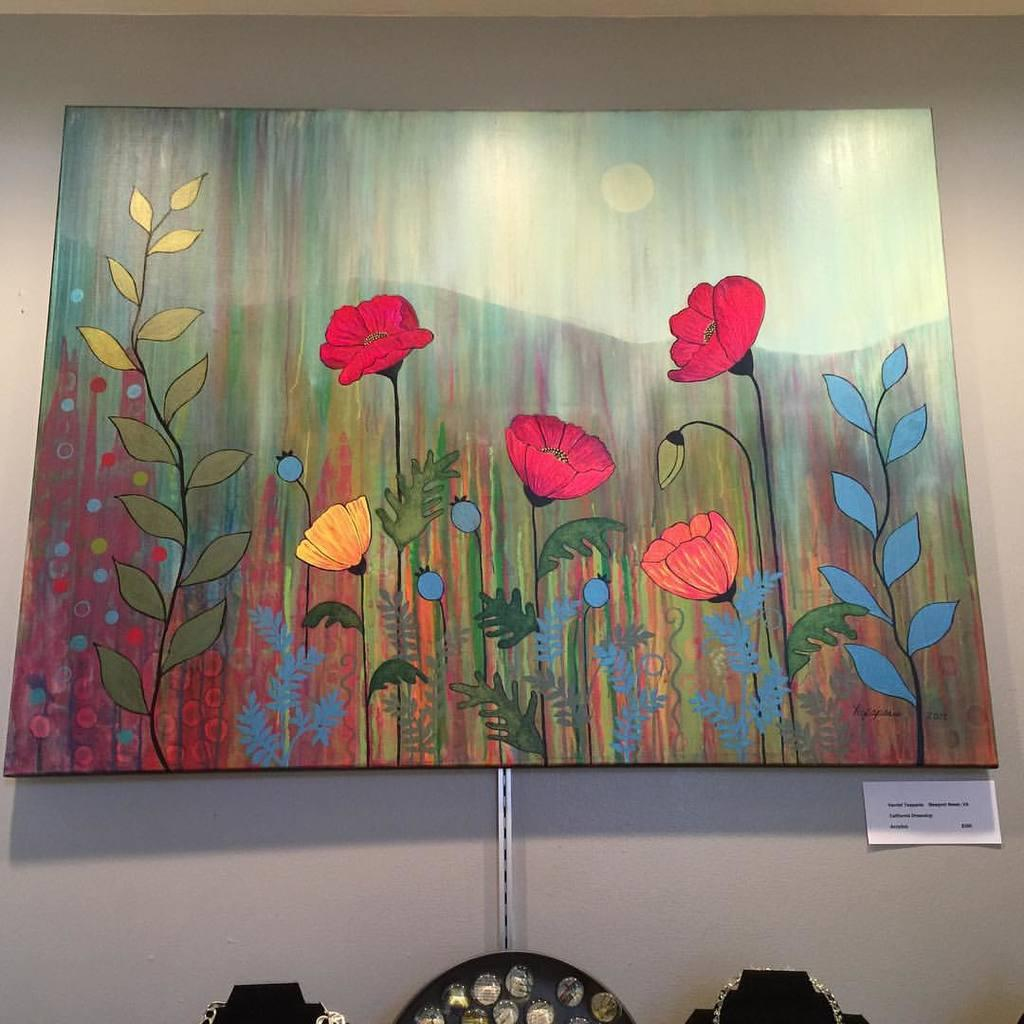What is present in the image that has a border or edge? There is a frame in the image. What is inside the frame? The frame contains flowers, leaves, mountains, and a depiction of the sky. Where is the paper located in the image? The paper is on the wall in the image. What type of juice can be seen in the frame? There is no juice present in the frame; it contains flowers, leaves, mountains, and a depiction of the sky. What scientific experiment is being conducted in the image? There is no scientific experiment depicted in the image; it features a frame with various elements. 